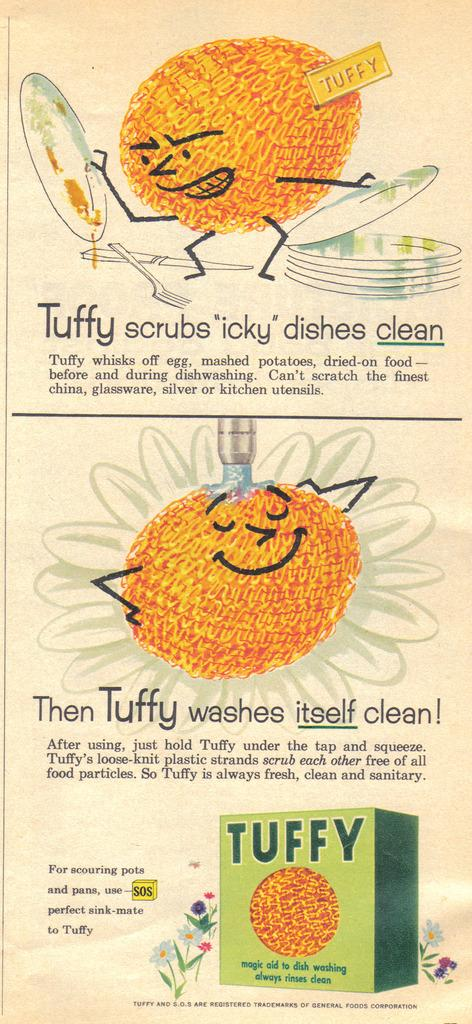What type of characters are present in the image? There are cartoon characters in the image. What else can be seen in the image besides the characters? There is text written in the image. Can you describe the green-colored object at the bottom of the image? There is a green-colored object at the bottom of the image. What type of stick can be seen being used by the cartoon characters in the image? There is no stick present in the image; it only features cartoon characters, text, and a green-colored object. 